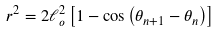<formula> <loc_0><loc_0><loc_500><loc_500>r ^ { 2 } = 2 \ell _ { o } ^ { 2 } \left [ 1 - \cos \left ( \theta _ { n + 1 } - \theta _ { n } \right ) \right ]</formula> 